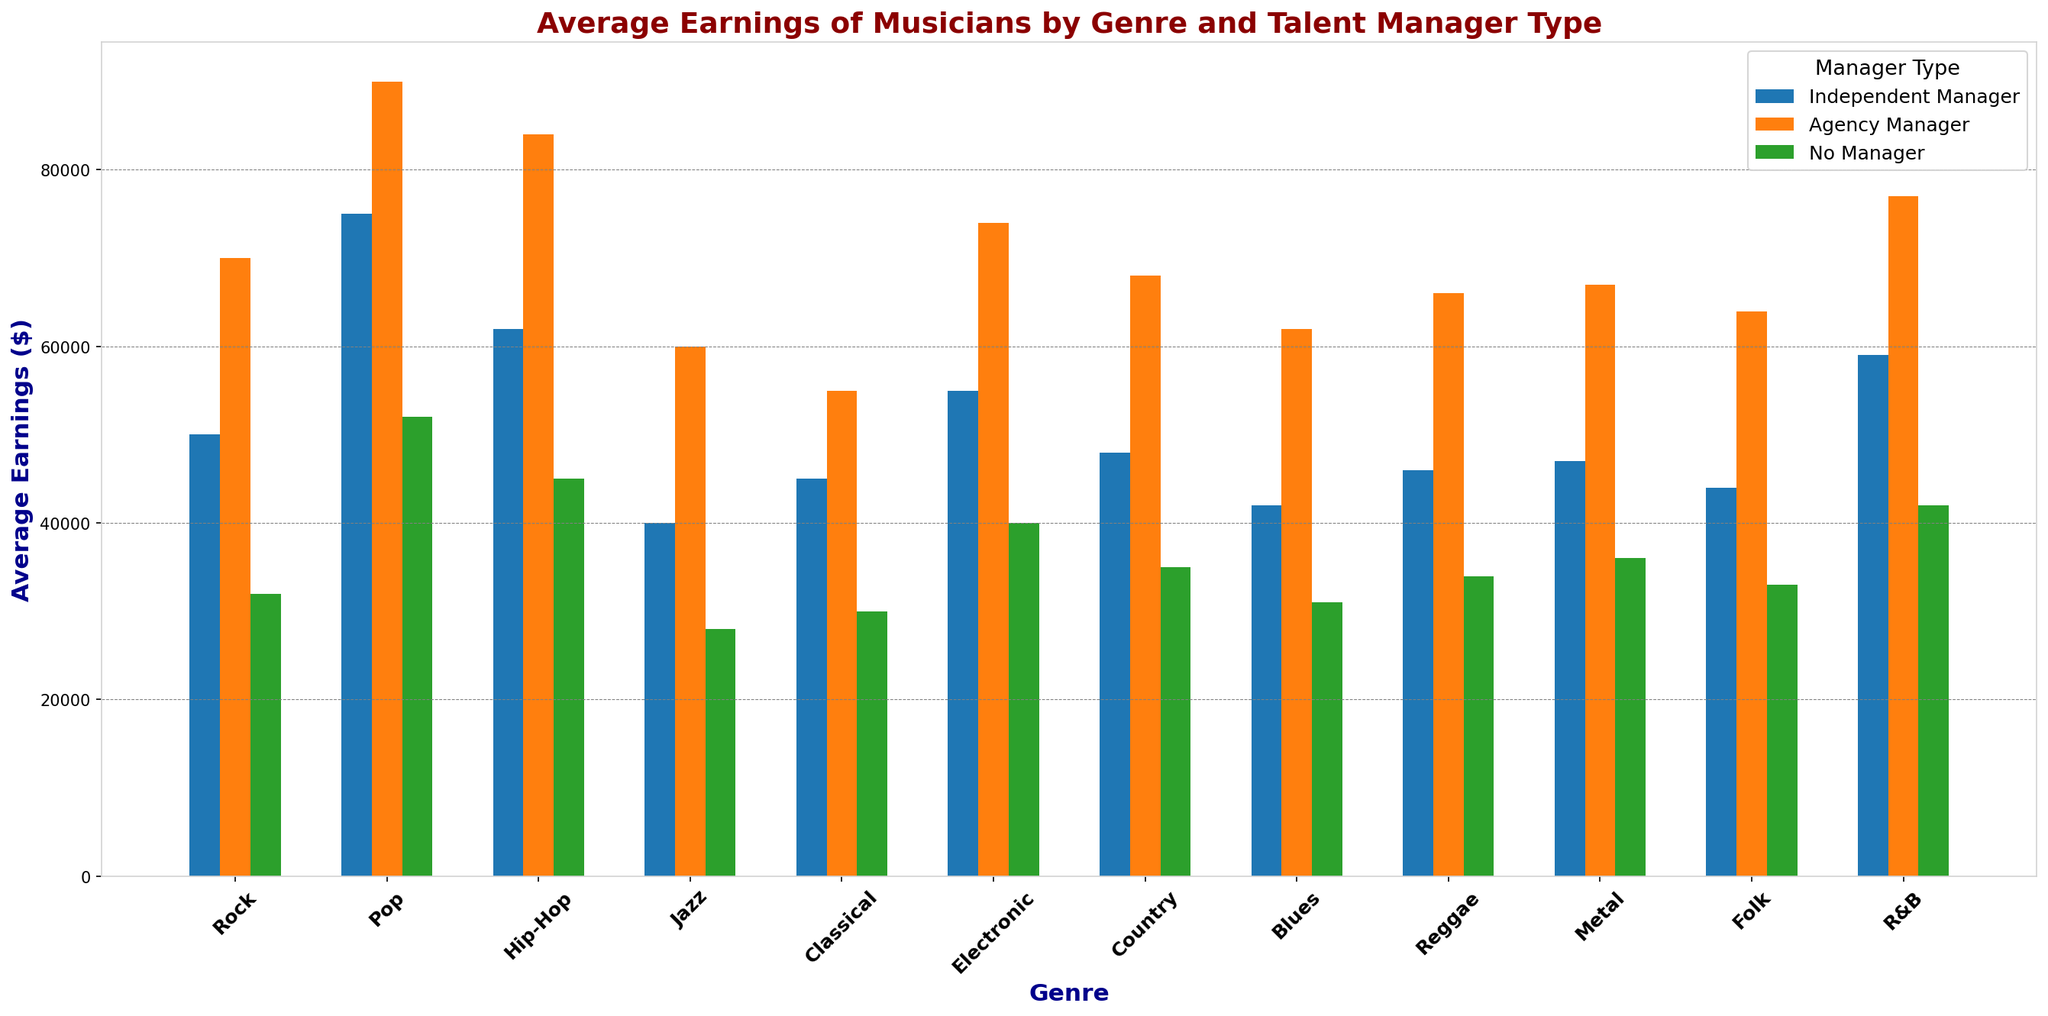What genre has the highest average earnings with an Agency Manager? By inspecting the bars for each genre, the highest bar under the "Agency Manager" category belongs to the Pop genre.
Answer: Pop Which talent manager type has the least average earnings for Classical musicians? By comparing the heights of the three bars representing Classical genre, the shortest bar is "No Manager."
Answer: No Manager How much more do Hip-Hop musicians earn on average with an Agency Manager compared to without any manager? Compare the heights of the bars for Hip-Hop under "Agency Manager" and "No Manager." The difference is 84,000 - 45,000 = 39,000.
Answer: 39,000 Which genre exhibits the smallest difference in average earnings between Independent Manager and No Manager? Calculate the difference between "Independent Manager" and "No Manager" for each genre. Classical has one of the smallest differences: 45,000 - 30,000 = 15,000.
Answer: Classical Compare the earning potential for Rock musicians with an Independent Manager versus Pop musicians with no manager. The height of the bar for Rock with "Independent Manager" is 50,000, and for Pop with "No Manager" is 52,000. So, Pop musicians with no manager earn 2,000 more.
Answer: Pop musicians with no manager What is the total average earnings for Country musicians across all manager types? Sum the Country earnings for "Independent Manager," "Agency Manager," and "No Manager": 48,000 + 68,000 + 35,000 = 151,000.
Answer: 151,000 Which genre shows the highest increase in average earnings from No Manager to Independent Manager? Calculate the increase for each genre. Rock has an increase from 32,000 to 50,000, resulting in 18,000. Each genre needs individual calculation for accurate comparison. The one with the highest difference is considered.
Answer: Rock For which music genre is the earnings difference between Agency Manager and Independent Manager exactly 20,000? Compare the difference for each genre. Jazz shows a difference: 60,000 - 40,000 = 20,000.
Answer: Jazz Which group has the highest visual contrast in bar heights, and what is the contrast for that genre? Visual contrast is seen where the height difference is maximized between the highest and lowest bars. Pop shows this with 90,000 (Agency Manager) vs. 52,000 (No Manager) = 38,000.
Answer: Pop, 38,000 